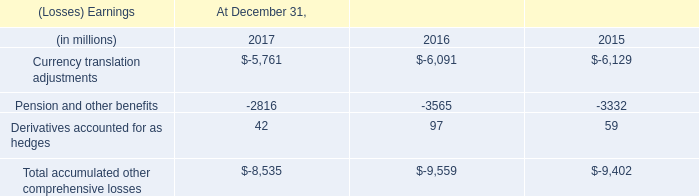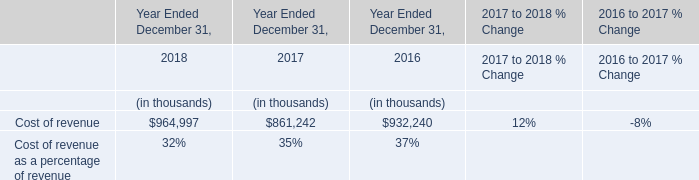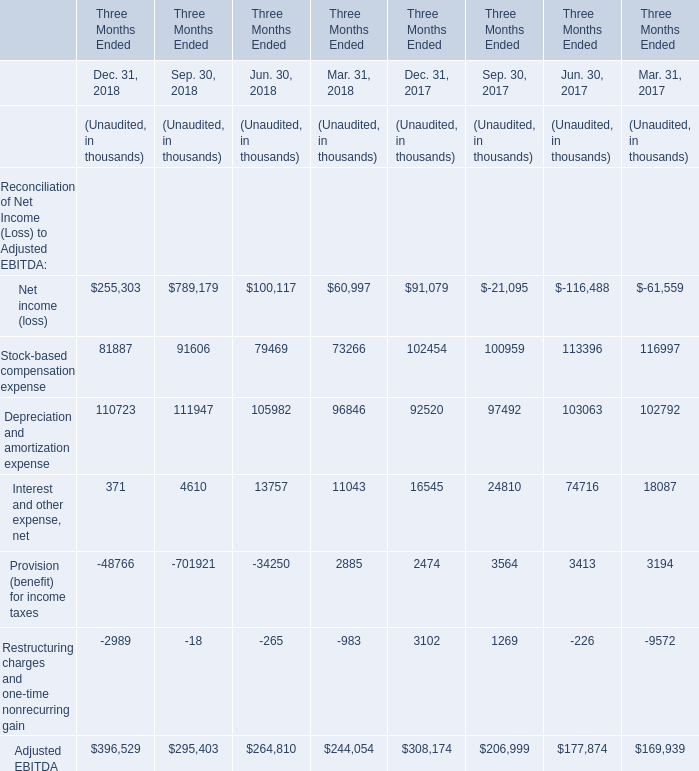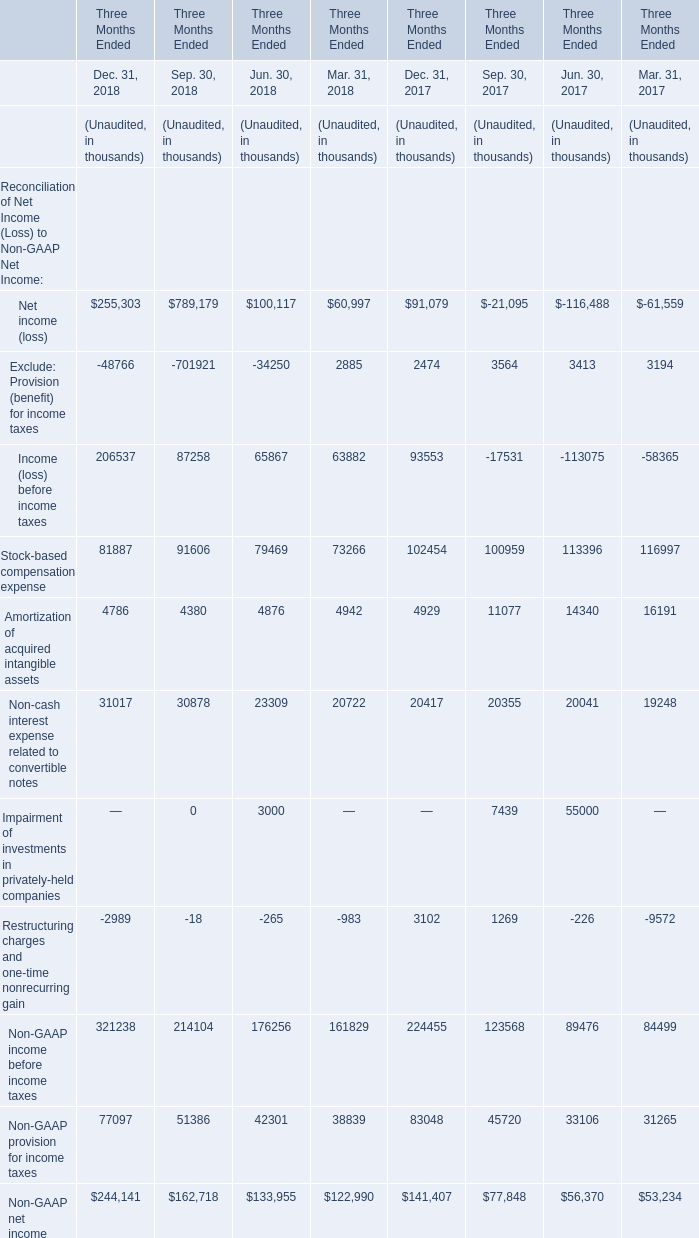How much of Dec. 31, 2018 is there in total without Provision (benefit) for income taxes and Restructuring charges and one-time nonrecurring gain? (in thousand) 
Computations: (((255303 + 81887) + 110723) + 371)
Answer: 448284.0. 